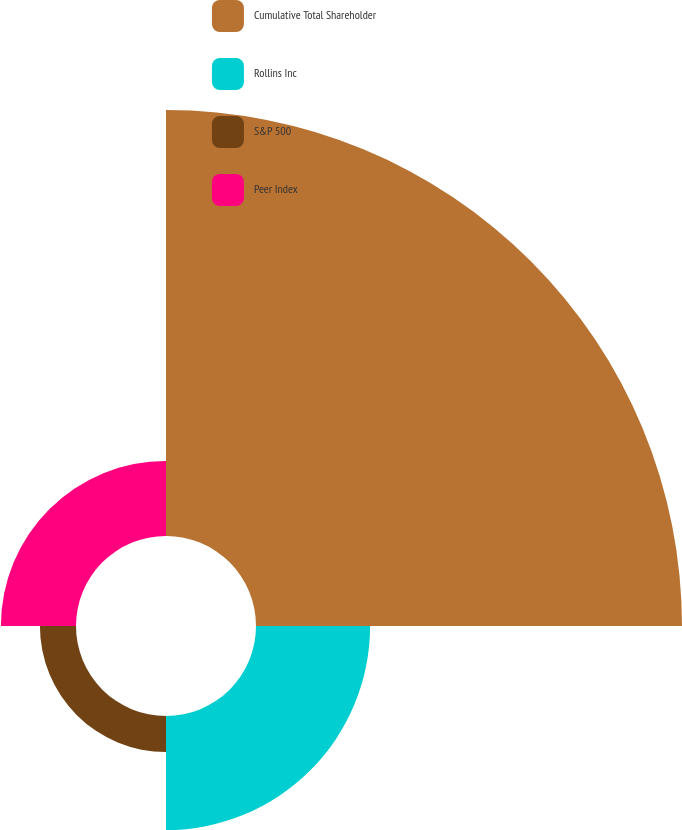<chart> <loc_0><loc_0><loc_500><loc_500><pie_chart><fcel>Cumulative Total Shareholder<fcel>Rollins Inc<fcel>S&P 500<fcel>Peer Index<nl><fcel>65.41%<fcel>17.52%<fcel>5.54%<fcel>11.53%<nl></chart> 